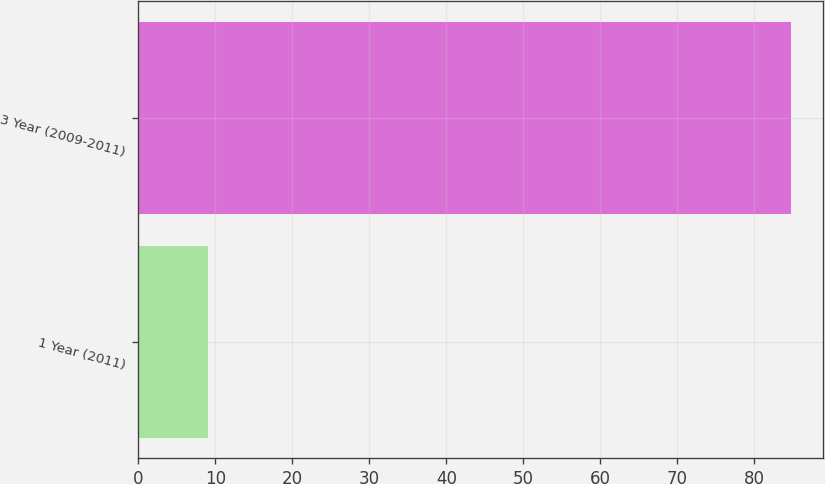Convert chart to OTSL. <chart><loc_0><loc_0><loc_500><loc_500><bar_chart><fcel>1 Year (2011)<fcel>3 Year (2009-2011)<nl><fcel>9<fcel>84.7<nl></chart> 